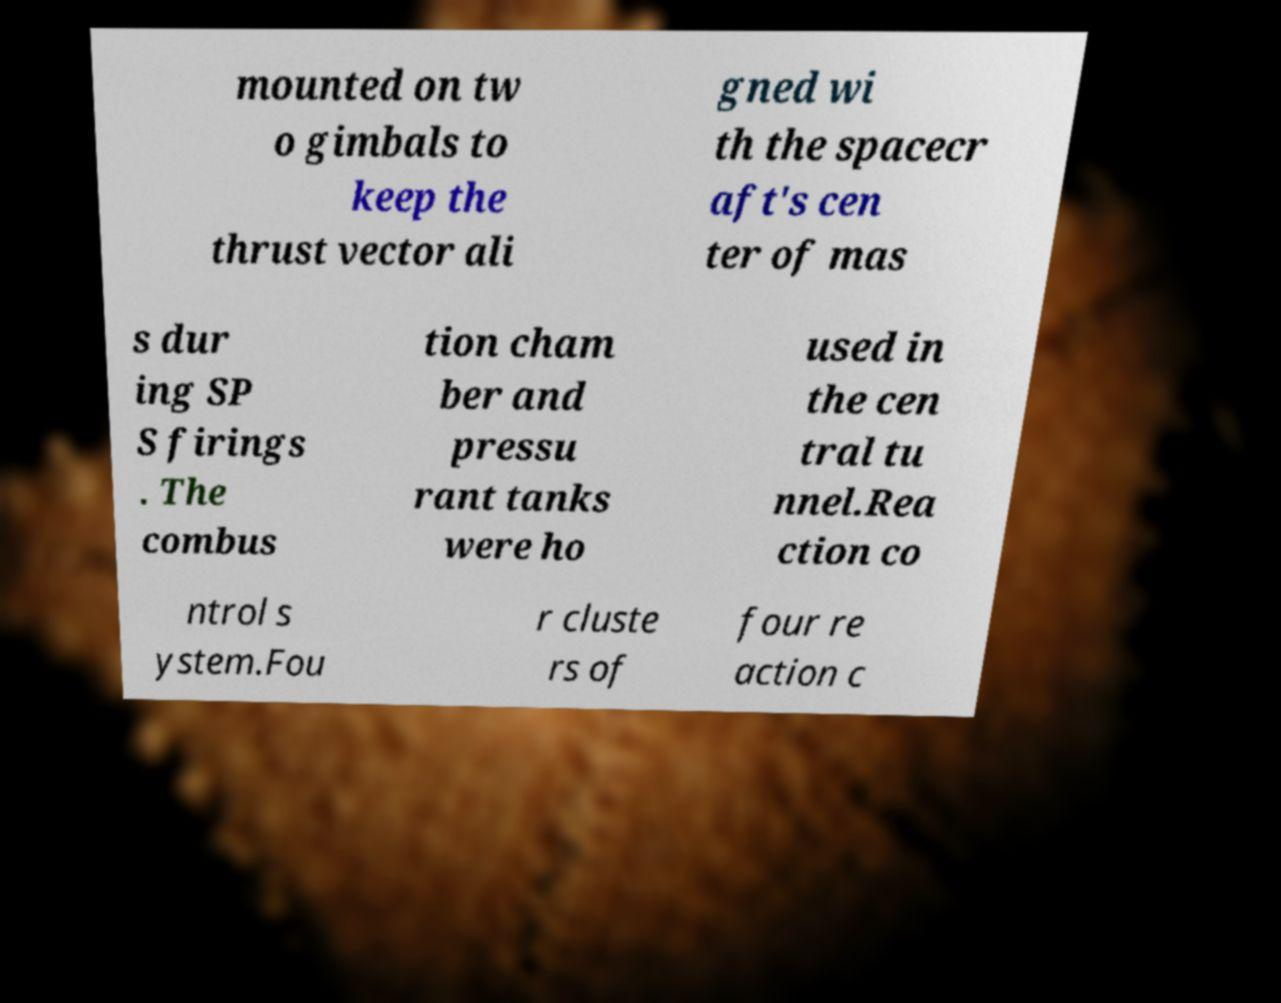For documentation purposes, I need the text within this image transcribed. Could you provide that? mounted on tw o gimbals to keep the thrust vector ali gned wi th the spacecr aft's cen ter of mas s dur ing SP S firings . The combus tion cham ber and pressu rant tanks were ho used in the cen tral tu nnel.Rea ction co ntrol s ystem.Fou r cluste rs of four re action c 